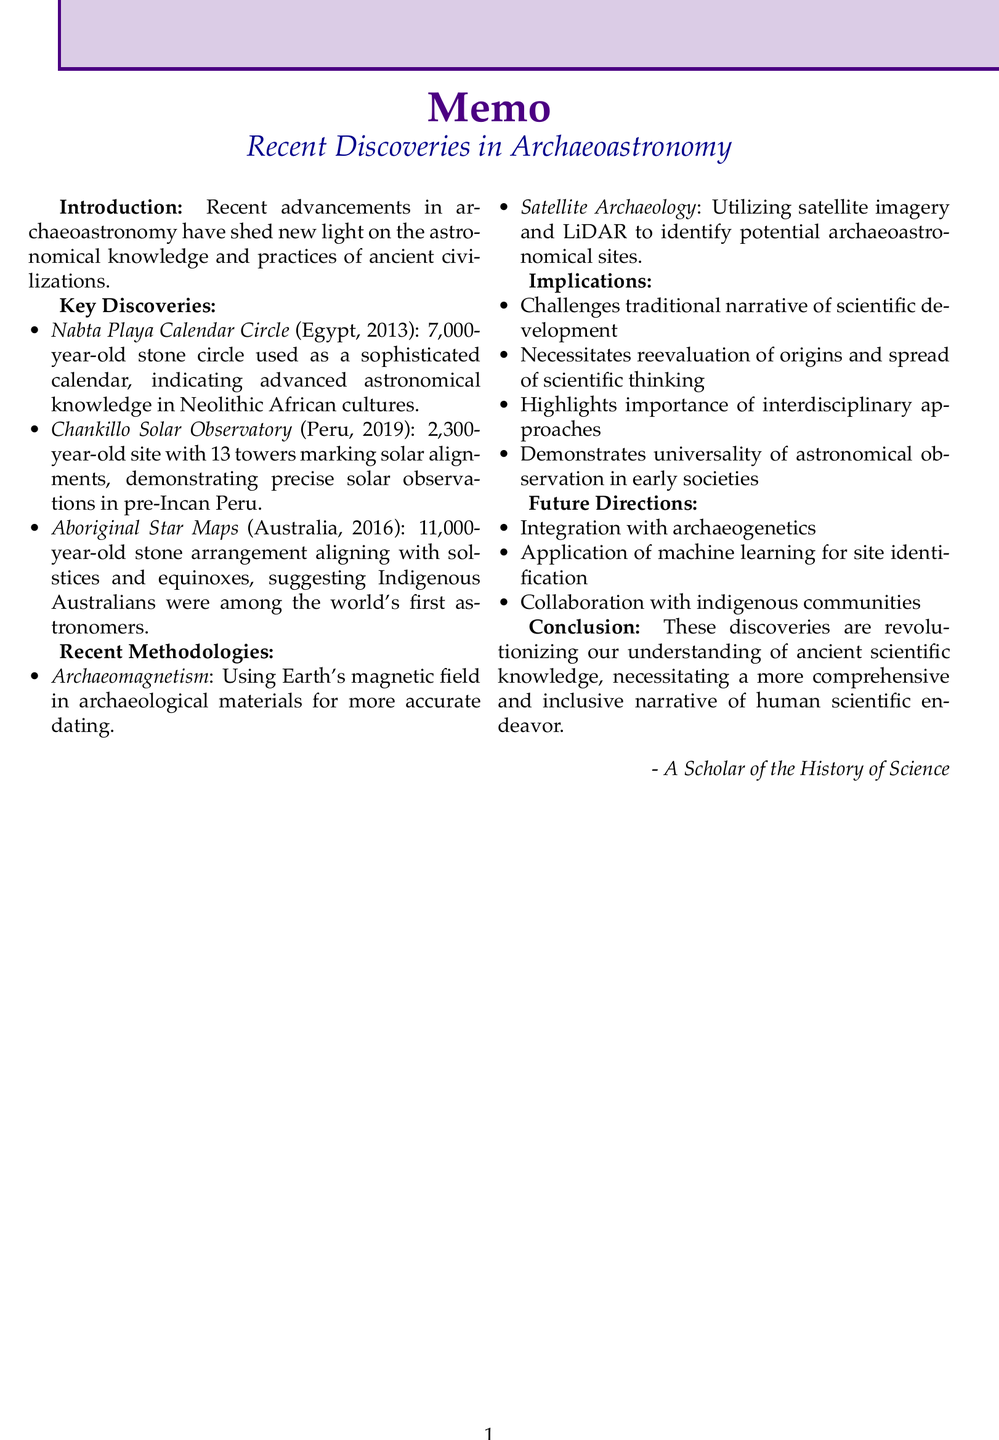what is the title of the memo? The title of the memo is stated at the beginning and clearly outlines the subject matter.
Answer: Recent Discoveries in Archaeoastronomy and Ancient Scientific Knowledge where is the Nabta Playa Calendar Circle located? The location of the Nabta Playa Calendar Circle is specified in the key discoveries section.
Answer: Nubian Desert, Egypt what year was the Chankillo Solar Observatory discovered? The year of discovery for the Chankillo Solar Observatory is mentioned along with its key details.
Answer: 2019 how old is the stone arrangement at Wurdi Youang? The age of the stone arrangement at Wurdi Youang is included in the description of key discoveries.
Answer: over 11,000 years ago which methodology uses LiDAR technology? The methodology that utilizes LiDAR technology is outlined among the recent methodologies.
Answer: Satellite Archaeology what implication does the recent discoveries challenge? The implications of the discoveries are summarized, indicating a specific challenge to historical views.
Answer: traditional narrative of scientific development what future direction involves machine learning? Future directions mention the application of machine learning, indicating a focus on technological integration.
Answer: Application of machine learning for site identification what year was the reanalysis of the Nabta Playa Calendar Circle conducted? The year of the reanalysis for the Nabta Playa Calendar Circle can be found in the key discoveries section.
Answer: 2013 who might collaborate with researchers on future projects? The document suggests collaboration with a specific group for future research directions.
Answer: indigenous communities 